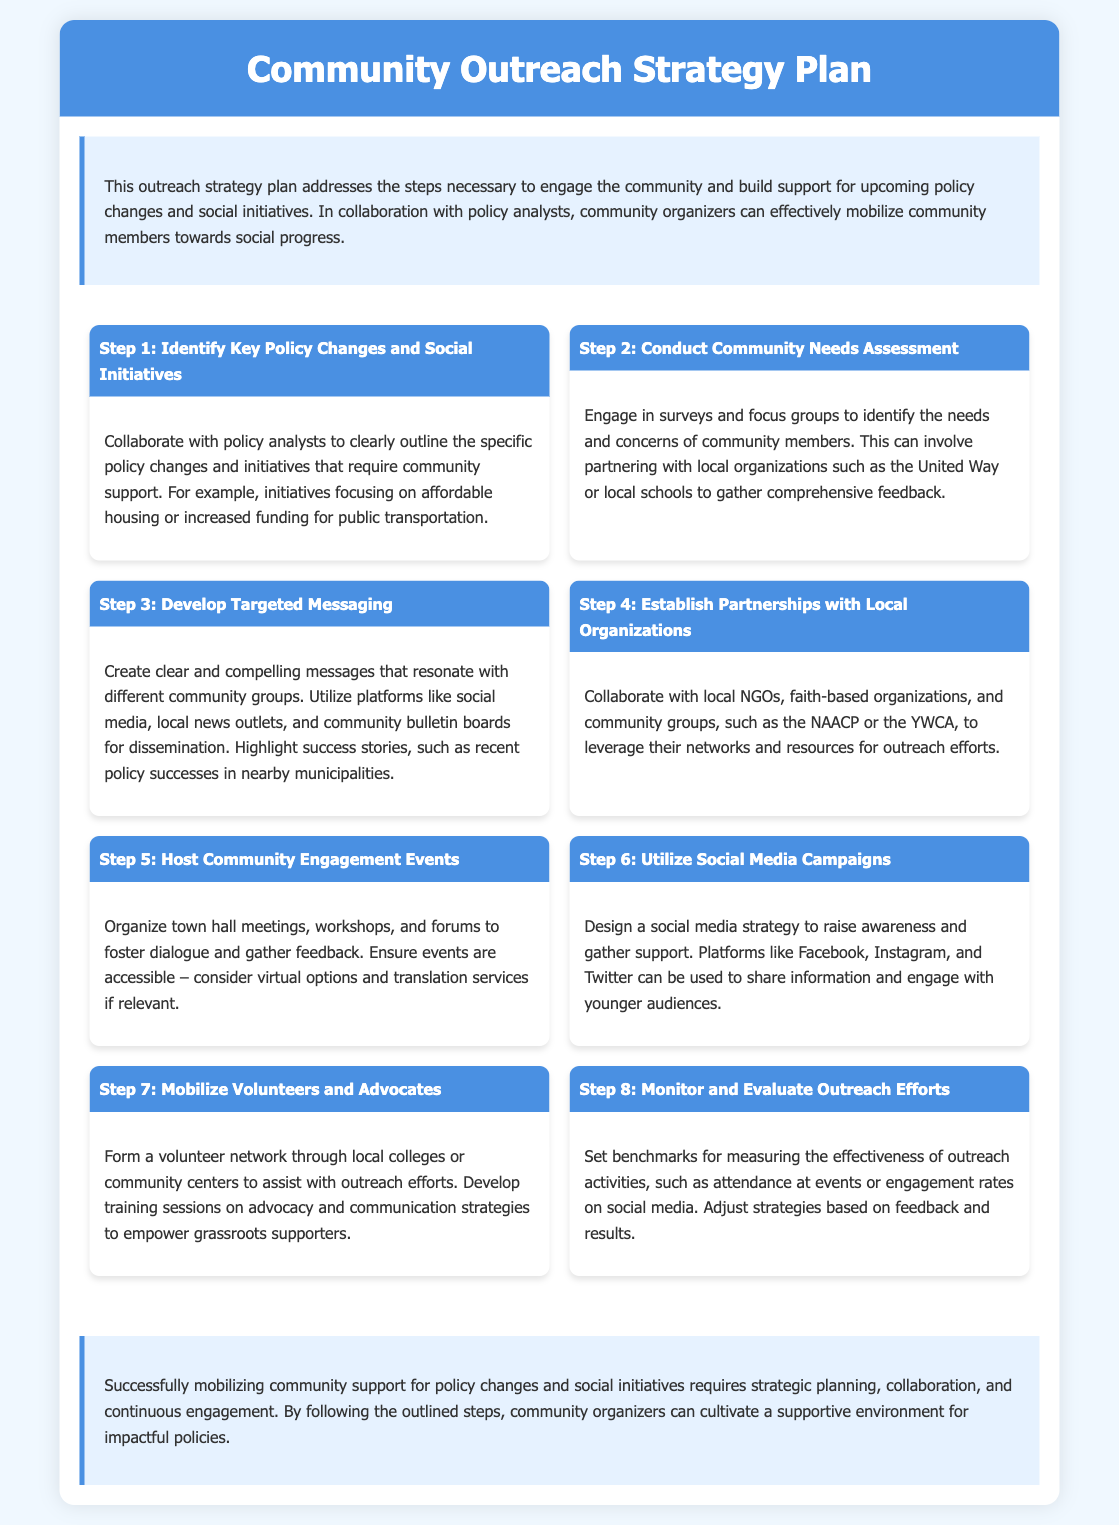What is the title of the document? The title of the document is stated clearly at the top of the content section.
Answer: Community Outreach Strategy Plan How many steps are outlined in the strategy plan? The document details the number of steps that are essential for mobilizing community support.
Answer: Eight What is the focus of Step 2? The content of Step 2 discusses a particular action necessary for understanding community needs.
Answer: Conduct Community Needs Assessment Which organization is mentioned as a potential partner in Step 4? Step 4 identifies specific types of organizations that can assist in outreach.
Answer: NAACP What type of events does Step 5 recommend hosting? The type of events suggested in Step 5 for community engagement is specified.
Answer: Community Engagement Events What social media platforms are suggested in Step 6? The document lists specific social media platforms that can be used for outreach efforts.
Answer: Facebook, Instagram, Twitter What is the purpose of establishing partnerships in Step 4? The rationale behind building partnerships is given in Step 4.
Answer: Leverage networks and resources What is the main goal outlined in the conclusion? The conclusion summarizes the overall aim of following the outlined steps.
Answer: Cultivate a supportive environment for impactful policies 